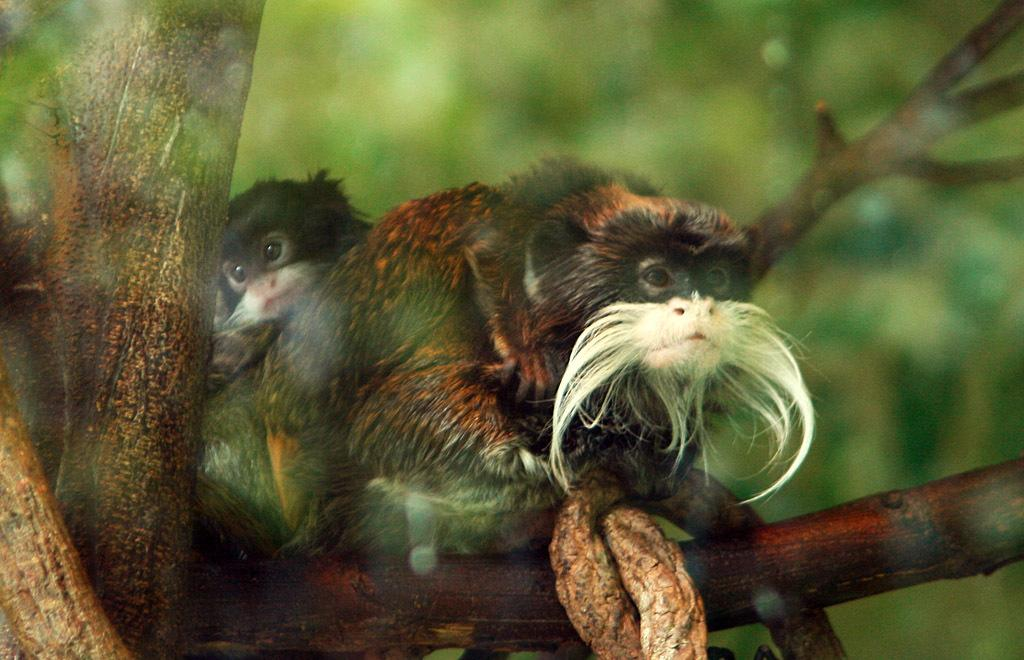What animals are in the image? There are two bearded monkeys in the image. Where are the monkeys located? The monkeys are on a branch. Can you describe the background of the image? The background of the image is blurred. What type of silver cake is being served to the monkeys in the image? There is no silver cake present in the image; it features two bearded monkeys on a branch. What soda brand can be seen in the hands of the monkeys in the image? There is no soda present in the image; it only shows two bearded monkeys on a branch. 